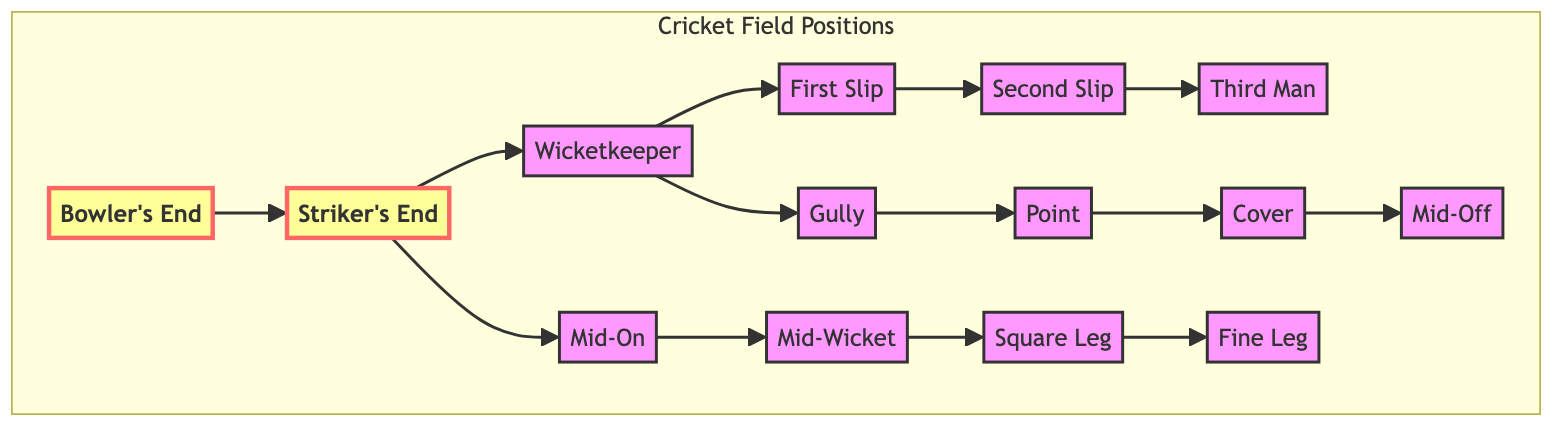What is the position at the Bowler's End? The diagram indicates that the position at the Bowler's End is labeled as "Bowler's End" or "BE."
Answer: Bowler's End How many slips are positioned next to the Wicketkeeper? The diagram shows two positions labeled as "First Slip" and "Second Slip" directly next to the Wicketkeeper.
Answer: Two What is the relationship between the Striker's End and Fine Leg? The Striker's End flows to Mid-On, which then connects sequentially through Mid-Wicket, Square Leg, and culminates at Fine Leg.
Answer: Striker's End --> Fine Leg Which position is directly next to the Wicketkeeper? The diagram shows that the position directly next to the Wicketkeeper is labeled as "First Slip."
Answer: First Slip What is the last position on the right side of the diagram? Following the flow from the Wicketkeeper, the last position listed on the right side is "Fine Leg."
Answer: Fine Leg What are the positions in the order from the Wicketkeeper towards the slips? The positions in order from the Wicketkeeper are "First Slip," then "Second Slip," and finally "Third Man."
Answer: First Slip, Second Slip, Third Man What category do positions like Point and Cover belong to? These positions ("Point" and "Cover") are located in the area surrounding the Wicketkeeper from his perspective, positioned on the off side of the field.
Answer: Off-side How many total field positions are represented in the diagram? By counting all the unique positions labeled in the diagram, you will find that there are 13 distinct field positions.
Answer: Thirteen What is the sequential flow from Bowler's End to Wicketkeeper? The flow begins at the Bowler's End, directly connects to the Striker's End, and then flows to the Wicketkeeper, making it a direct transition across the diagram.
Answer: Bowler's End to Wicketkeeper 